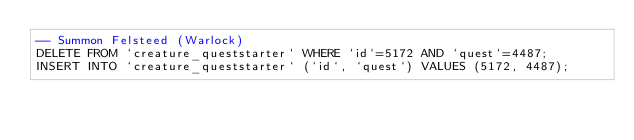Convert code to text. <code><loc_0><loc_0><loc_500><loc_500><_SQL_>-- Summon Felsteed (Warlock)
DELETE FROM `creature_queststarter` WHERE `id`=5172 AND `quest`=4487;
INSERT INTO `creature_queststarter` (`id`, `quest`) VALUES (5172, 4487);
</code> 